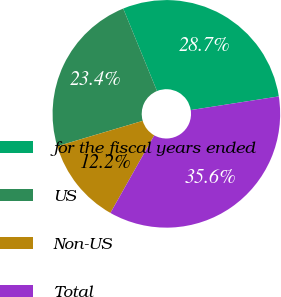Convert chart. <chart><loc_0><loc_0><loc_500><loc_500><pie_chart><fcel>for the fiscal years ended<fcel>US<fcel>Non-US<fcel>Total<nl><fcel>28.74%<fcel>23.4%<fcel>12.23%<fcel>35.63%<nl></chart> 